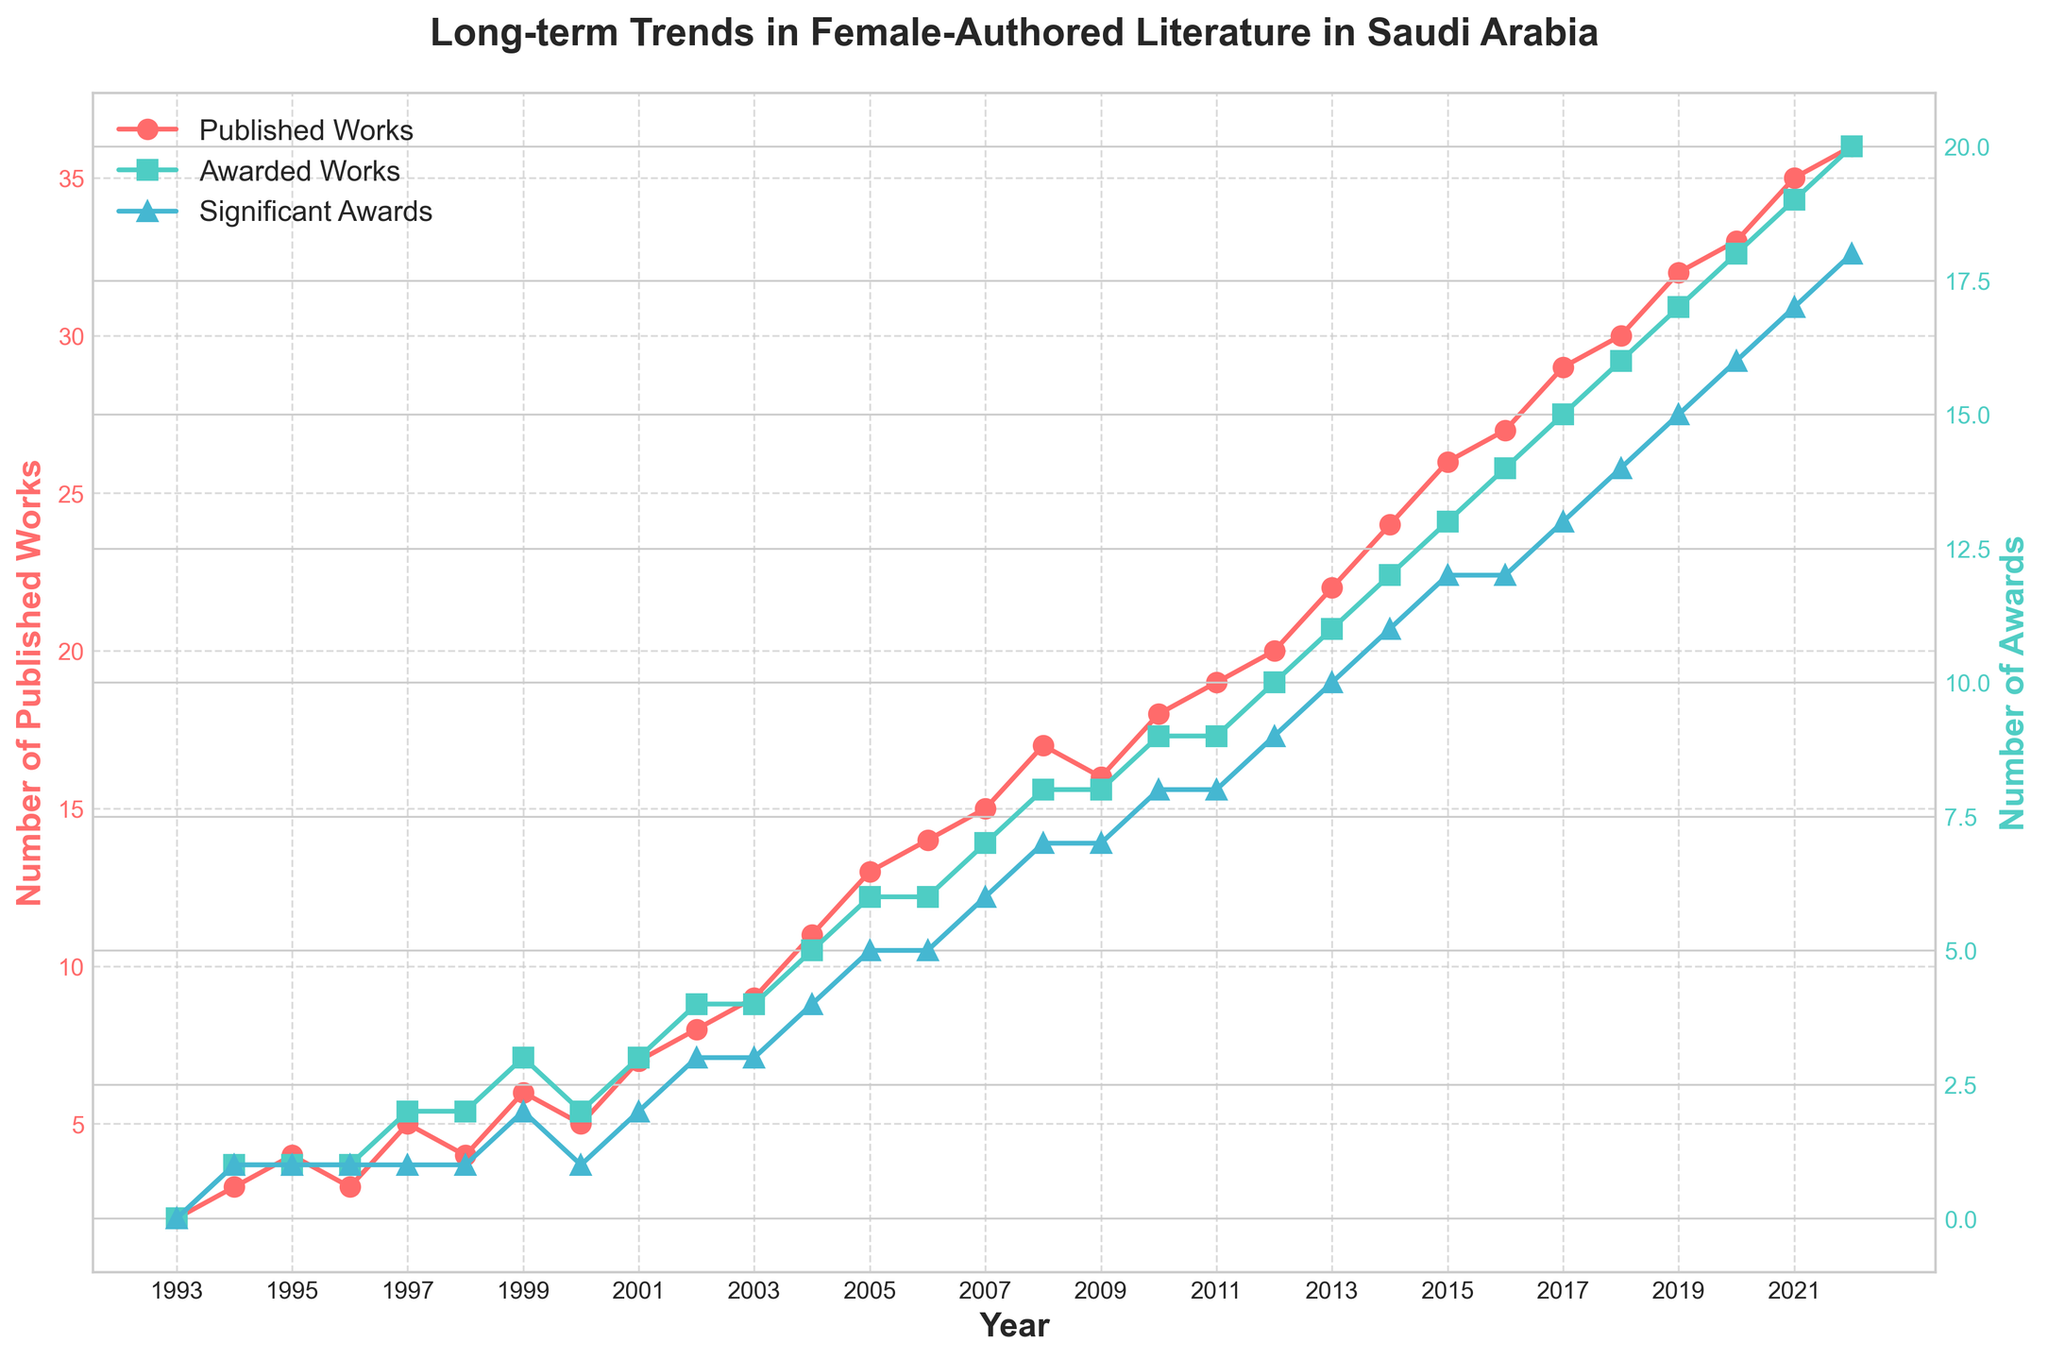What is the title of the plot? The title is a text at the top of the plot that explains what the visualized data represents. In this plot, the title can be read directly at the top.
Answer: Long-term Trends in Female-Authored Literature in Saudi Arabia What is the x-axis label, and what does it represent? The x-axis label is located at the horizontal axis and describes what the data points on that axis represent. In this plot, it represents the time period of the data.
Answer: Year How many published works were there in 2010? To find the number of published works for the year 2010, locate the year 2010 on the x-axis and follow the plot line for published works to see its corresponding y-value.
Answer: 18 Which color represents the awarded works, and how many award-winning works were there in 2005? The color representing awarded works can be identified by examining the plot legend. Follow the awarded works plot line to the year 2005 to find the y-value.
Answer: Turquoise (#4ECDC4), 6 In which year did the number of significant awards first reach 10? To find when the significant awards first reached 10, follow the significant awards marker and line (colored in blue) and identify the first year where it crosses the y-value of 10.
Answer: 2013 Compare the number of awarded works and significant awards in 2020. Which one is higher, and by how much? To compare the two quantities for the year 2020, locate the year on the x-axis and check the y-values for both awarded works and significant awards. Compare their values and compute the difference.
Answer: Awarded works are higher by 2 (18 vs 16) What is the trend of published works over the 30 years? Observe the overall direction of the published works plot line from 1993 to 2022. Describe whether it is generally increasing, decreasing, or staying constant.
Answer: Increasing How many total published works were there from 2015 to 2020? Identify the y-value for the number of published works in each year from 2015 to 2020, and sum them up.
Answer: 26 (2015) + 27 (2016) + 29 (2017) + 30 (2018) + 32 (2019) + 33 (2020) = 177 Between which consecutive years was the increase in the number of published works the highest? Calculate the difference in published works between each consecutive year and identify the pair of years with the maximum difference.
Answer: 2014 to 2015 What is the average number of significant awards from 2000 to 2010? Identify the y-values for significant awards from each year within this range, sum them up, and divide by the number of years to get the average.
Answer: (1 + 2 + 2 + 3 + 3 + 4 + 5 + 5 + 6 + 7 + 7 + 8 + 8) / 11 ≈ 4.55 